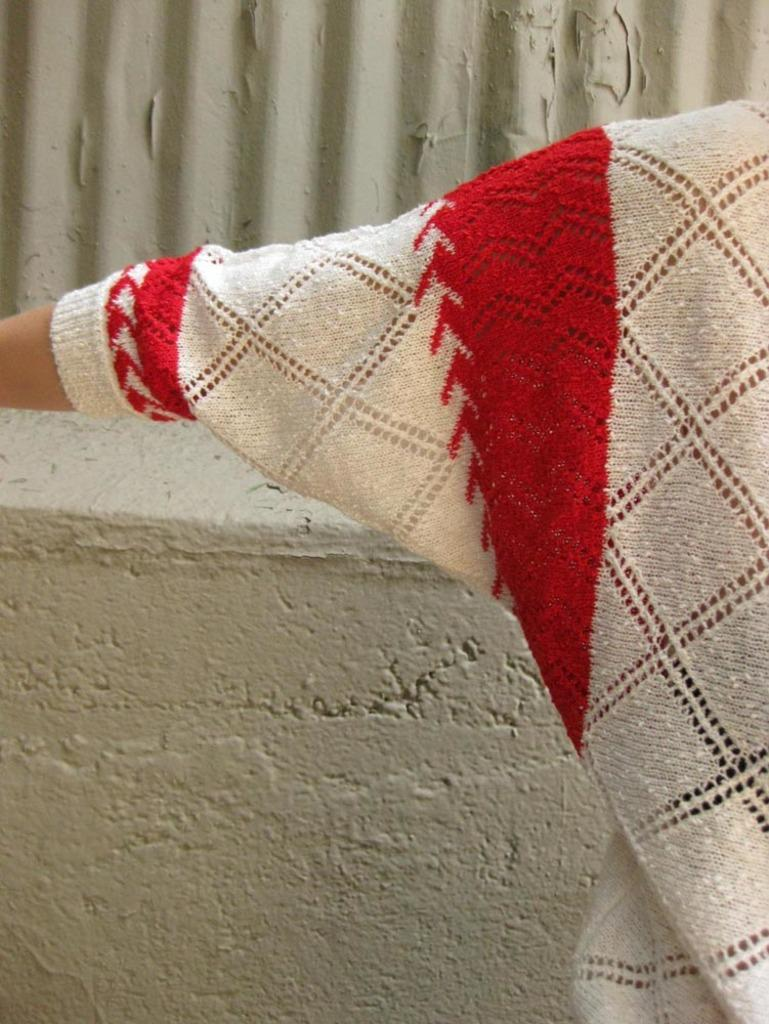What is located at the bottom of the image? There is a wall at the bottom of the image. What part of a person can be seen in the image? A human hand is visible in the image. What type of clothing is the person wearing in the image? The person in the image is wearing a sweater. What type of pie is being served on a plate in the image? There is no pie present in the image; only a wall, a human hand, and a sweater-wearing person are visible. 